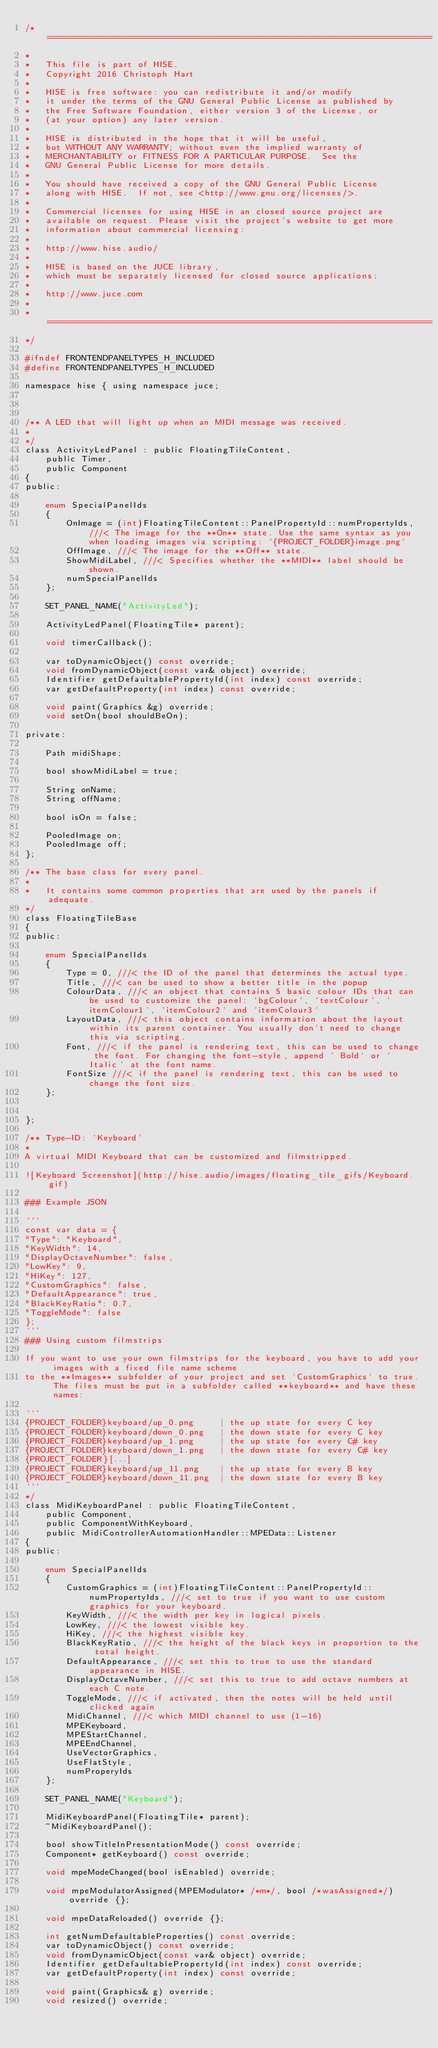Convert code to text. <code><loc_0><loc_0><loc_500><loc_500><_C_>/*  ===========================================================================
*
*   This file is part of HISE.
*   Copyright 2016 Christoph Hart
*
*   HISE is free software: you can redistribute it and/or modify
*   it under the terms of the GNU General Public License as published by
*   the Free Software Foundation, either version 3 of the License, or
*   (at your option) any later version.
*
*   HISE is distributed in the hope that it will be useful,
*   but WITHOUT ANY WARRANTY; without even the implied warranty of
*   MERCHANTABILITY or FITNESS FOR A PARTICULAR PURPOSE.  See the
*   GNU General Public License for more details.
*
*   You should have received a copy of the GNU General Public License
*   along with HISE.  If not, see <http://www.gnu.org/licenses/>.
*
*   Commercial licenses for using HISE in an closed source project are
*   available on request. Please visit the project's website to get more
*   information about commercial licensing:
*
*   http://www.hise.audio/
*
*   HISE is based on the JUCE library,
*   which must be separately licensed for closed source applications:
*
*   http://www.juce.com
*
*   ===========================================================================
*/

#ifndef FRONTENDPANELTYPES_H_INCLUDED
#define FRONTENDPANELTYPES_H_INCLUDED

namespace hise { using namespace juce;



/** A LED that will light up when an MIDI message was received.
*
*/
class ActivityLedPanel : public FloatingTileContent,
	public Timer,
	public Component
{
public:

	enum SpecialPanelIds
	{
		OnImage = (int)FloatingTileContent::PanelPropertyId::numPropertyIds, ///< The image for the **On** state. Use the same syntax as you when loading images via scripting: `{PROJECT_FOLDER}image.png`
		OffImage, ///< The image for the **Off** state.
		ShowMidiLabel, ///< Specifies whether the **MIDI** label should be shown.
		numSpecialPanelIds
	};

	SET_PANEL_NAME("ActivityLed");

	ActivityLedPanel(FloatingTile* parent);

	void timerCallback();

	var toDynamicObject() const override;
	void fromDynamicObject(const var& object) override;
	Identifier getDefaultablePropertyId(int index) const override;
	var getDefaultProperty(int index) const override;

	void paint(Graphics &g) override;
	void setOn(bool shouldBeOn);

private:

	Path midiShape;

	bool showMidiLabel = true;

	String onName;
	String offName;

	bool isOn = false;

	PooledImage on;
	PooledImage off;
};

/** The base class for every panel.
*
*	It contains some common properties that are used by the panels if adequate.
*/
class FloatingTileBase
{
public:

	enum SpecialPanelIds
	{
		Type = 0, ///< the ID of the panel that determines the actual type.
		Title, ///< can be used to show a better title in the popup
		ColourData, ///< an object that contains 5 basic colour IDs that can be used to customize the panel: `bgColour`, `textColour`, `itemColour1`, `itemColour2` and `itemColour3`
		LayoutData, ///< this object contains information about the layout within its parent container. You usually don't need to change this via scripting.
		Font, ///< if the panel is rendering text, this can be used to change the font. For changing the font-style, append ` Bold` or ` Italic` at the font name.
		FontSize ///< if the panel is rendering text, this can be used to change the font size.
	};


};

/** Type-ID: `Keyboard`
*
A virtual MIDI Keyboard that can be customized and filmstripped.

![Keyboard Screenshot](http://hise.audio/images/floating_tile_gifs/Keyboard.gif)

### Example JSON

```
const var data = {
"Type": "Keyboard",
"KeyWidth": 14,
"DisplayOctaveNumber": false,
"LowKey": 9,
"HiKey": 127,
"CustomGraphics": false,
"DefaultAppearance": true,
"BlackKeyRatio": 0.7,
"ToggleMode": false
};
```
### Using custom filmstrips

If you want to use your own filmstrips for the keyboard, you have to add your images with a fixed file name scheme
to the **Images** subfolder of your project and set `CustomGraphics` to true. The files must be put in a subfolder called **keyboard** and have these names:

```
{PROJECT_FOLDER}keyboard/up_0.png	  | the up state for every C key
{PROJECT_FOLDER}keyboard/down_0.png   | the down state for every C key
{PROJECT_FOLDER}keyboard/up_1.png	  | the up state for every C# key
{PROJECT_FOLDER}keyboard/down_1.png	  | the down state for every C# key
{PROJECT_FOLDER}[...]
{PROJECT_FOLDER}keyboard/up_11.png    | the up state for every B key
{PROJECT_FOLDER}keyboard/down_11.png  | the down state for every B key
```
*/
class MidiKeyboardPanel : public FloatingTileContent,
	public Component,
	public ComponentWithKeyboard,
	public MidiControllerAutomationHandler::MPEData::Listener
{
public:

	enum SpecialPanelIds
	{
		CustomGraphics = (int)FloatingTileContent::PanelPropertyId::numPropertyIds, ///< set to true if you want to use custom graphics for your keyboard.
		KeyWidth, ///< the width per key in logical pixels.
		LowKey, ///< the lowest visible key.
		HiKey, ///< the highest visible key.
		BlackKeyRatio, ///< the height of the black keys in proportion to the total height.
		DefaultAppearance, ///< set this to true to use the standard appearance in HISE.
		DisplayOctaveNumber, ///< set this to true to add octave numbers at each C note.
		ToggleMode, ///< if activated, then the notes will be held until clicked again
		MidiChannel, ///< which MIDI channel to use (1-16)
		MPEKeyboard,
		MPEStartChannel,
		MPEEndChannel,
		UseVectorGraphics,
		UseFlatStyle,
		numProperyIds
	};

	SET_PANEL_NAME("Keyboard");

	MidiKeyboardPanel(FloatingTile* parent);
	~MidiKeyboardPanel();

	bool showTitleInPresentationMode() const override;
	Component* getKeyboard() const override;

	void mpeModeChanged(bool isEnabled) override;

	void mpeModulatorAssigned(MPEModulator* /*m*/, bool /*wasAssigned*/) override {};

	void mpeDataReloaded() override {};

	int getNumDefaultableProperties() const override;
	var toDynamicObject() const override;
	void fromDynamicObject(const var& object) override;
	Identifier getDefaultablePropertyId(int index) const override;
	var getDefaultProperty(int index) const override;

	void paint(Graphics& g) override;
	void resized() override;
</code> 